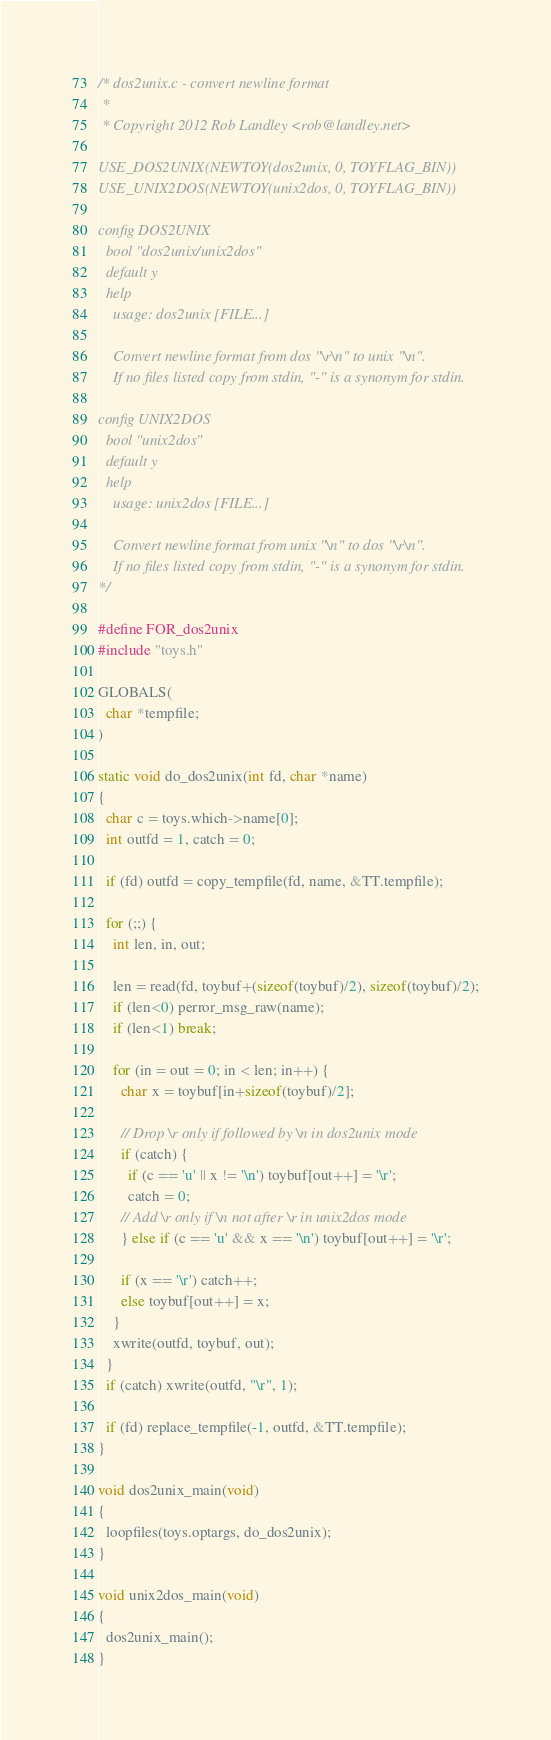Convert code to text. <code><loc_0><loc_0><loc_500><loc_500><_C_>/* dos2unix.c - convert newline format
 *
 * Copyright 2012 Rob Landley <rob@landley.net>

USE_DOS2UNIX(NEWTOY(dos2unix, 0, TOYFLAG_BIN))
USE_UNIX2DOS(NEWTOY(unix2dos, 0, TOYFLAG_BIN))

config DOS2UNIX
  bool "dos2unix/unix2dos"
  default y
  help
    usage: dos2unix [FILE...]

    Convert newline format from dos "\r\n" to unix "\n".
    If no files listed copy from stdin, "-" is a synonym for stdin.

config UNIX2DOS
  bool "unix2dos"
  default y
  help
    usage: unix2dos [FILE...]

    Convert newline format from unix "\n" to dos "\r\n".
    If no files listed copy from stdin, "-" is a synonym for stdin.
*/

#define FOR_dos2unix
#include "toys.h"

GLOBALS(
  char *tempfile;
)

static void do_dos2unix(int fd, char *name)
{
  char c = toys.which->name[0];
  int outfd = 1, catch = 0;

  if (fd) outfd = copy_tempfile(fd, name, &TT.tempfile);

  for (;;) {
    int len, in, out;

    len = read(fd, toybuf+(sizeof(toybuf)/2), sizeof(toybuf)/2);
    if (len<0) perror_msg_raw(name);
    if (len<1) break;

    for (in = out = 0; in < len; in++) {
      char x = toybuf[in+sizeof(toybuf)/2];

      // Drop \r only if followed by \n in dos2unix mode
      if (catch) {
        if (c == 'u' || x != '\n') toybuf[out++] = '\r';
        catch = 0;
      // Add \r only if \n not after \r in unix2dos mode
      } else if (c == 'u' && x == '\n') toybuf[out++] = '\r';

      if (x == '\r') catch++;
      else toybuf[out++] = x;
    }
    xwrite(outfd, toybuf, out);
  }
  if (catch) xwrite(outfd, "\r", 1);

  if (fd) replace_tempfile(-1, outfd, &TT.tempfile);
}

void dos2unix_main(void)
{
  loopfiles(toys.optargs, do_dos2unix);
}

void unix2dos_main(void)
{
  dos2unix_main();
}
</code> 